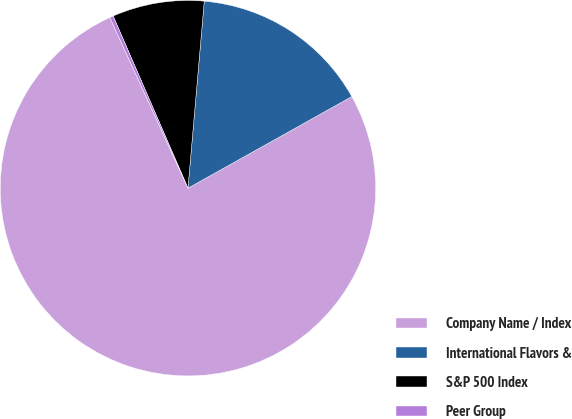Convert chart. <chart><loc_0><loc_0><loc_500><loc_500><pie_chart><fcel>Company Name / Index<fcel>International Flavors &<fcel>S&P 500 Index<fcel>Peer Group<nl><fcel>76.28%<fcel>15.5%<fcel>7.91%<fcel>0.31%<nl></chart> 